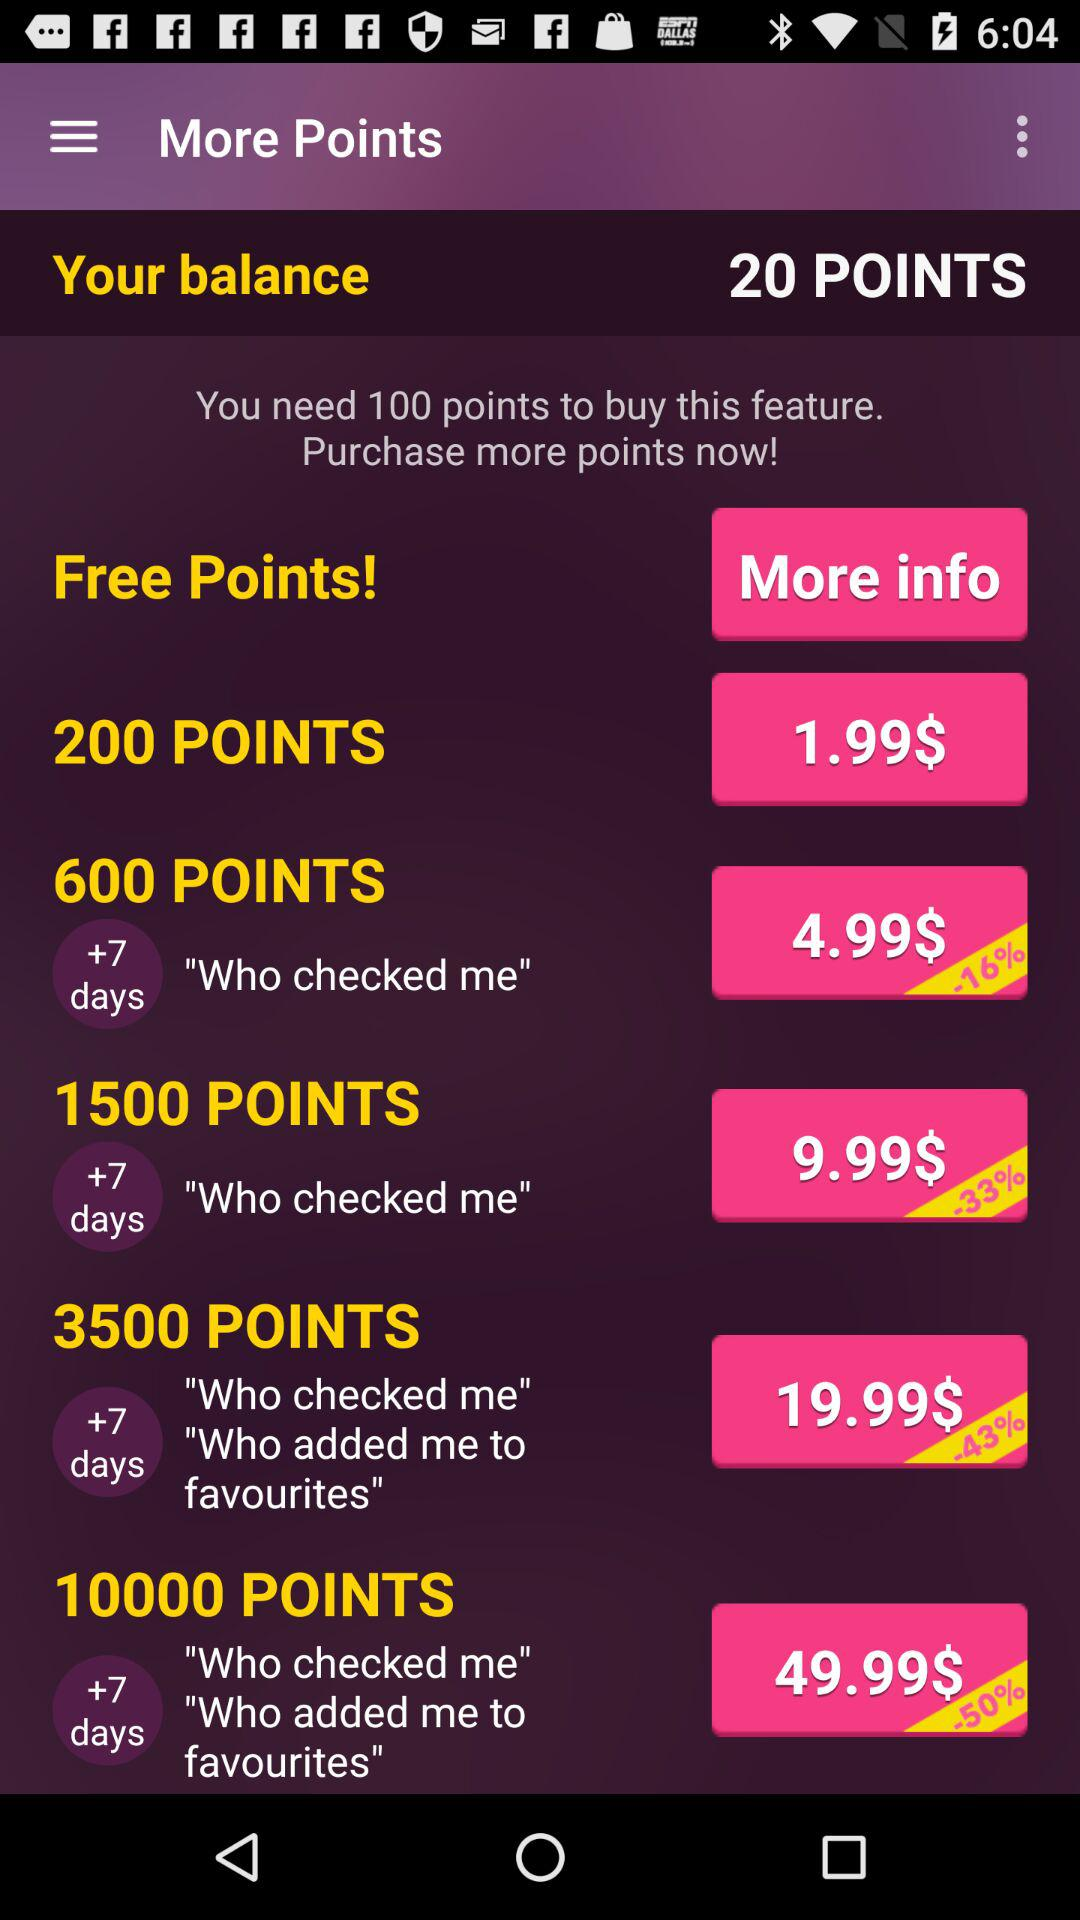What is the amount for 600 points? The amount is $4.99. 